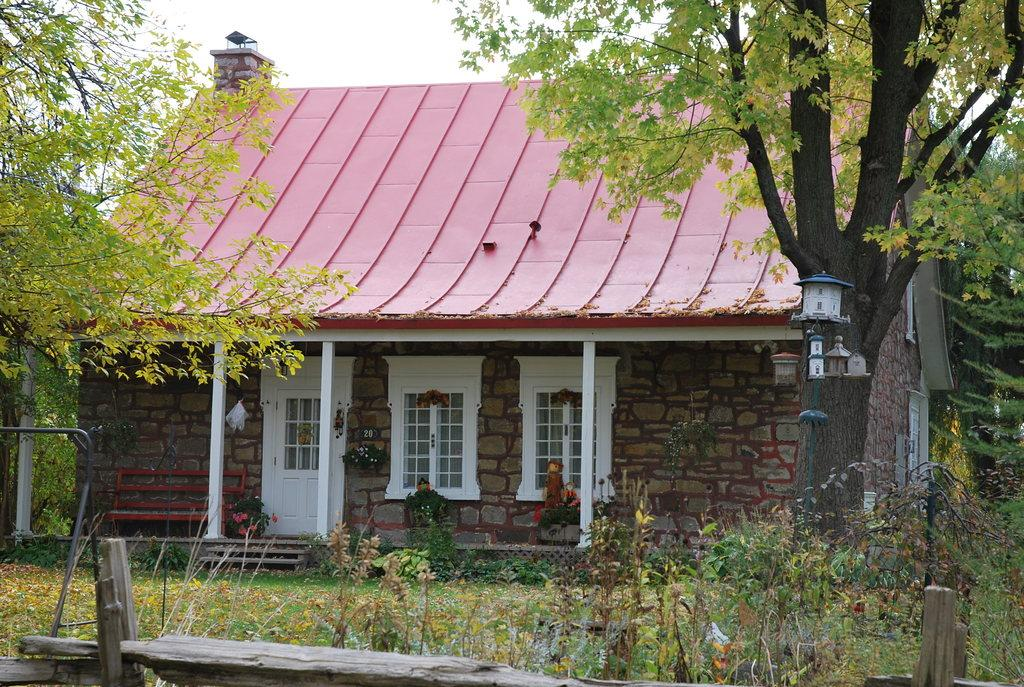What type of structure is in the picture? There is a house in the picture. What color are the windows of the house? The house has white windows. What is on top of the house? The house has a rooftop. What can be seen on the ground in the front bottom side of the picture? There are green plants on the ground in the front bottom side of the picture. What is located in the right corner of the picture? There is a tree in the right corner of the picture. What type of polish is being applied to the brain in the picture? There is no polish or brain present in the picture; it features a house with white windows, a rooftop, green plants, and a tree. 